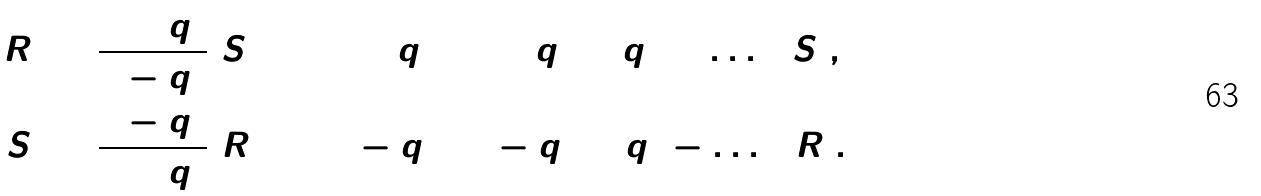Convert formula to latex. <formula><loc_0><loc_0><loc_500><loc_500>[ R ] & = \frac { 1 + q ^ { 2 } } { 1 - q ^ { 2 } } [ S ] = ( 1 + q ^ { 2 } ) ( 1 + q ^ { 2 } + q ^ { 4 } + \dots ) [ S ] , \\ [ S ] & = \frac { 1 - q ^ { 2 } } { 1 + q ^ { 2 } } [ R ] = ( 1 - q ^ { 2 } ) ( 1 - q ^ { 2 } + q ^ { 4 } - \dots ) [ R ] .</formula> 